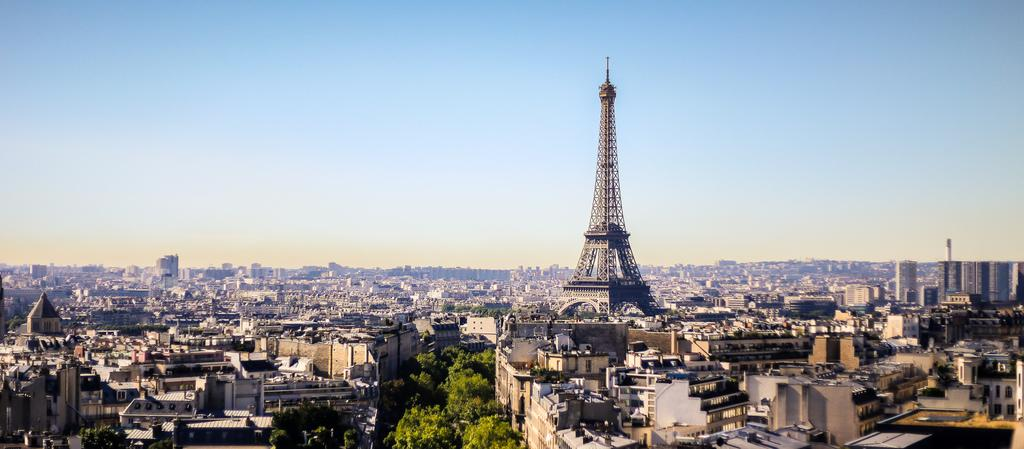What type of vegetation is at the bottom of the image? There are trees at the bottom of the image. What type of structures are in the middle of the image? There are buildings in the middle of the image. What famous landmark is present in the image? The Eiffel Tower is present in the image. What is visible at the top of the image? The sky is visible at the top of the image. What type of fruit is hanging from the trees at the bottom of the image? There is no fruit hanging from the trees in the image; only trees are present. What sign can be seen directing people to the Eiffel Tower in the image? There is no sign directing people to the Eiffel Tower in the image; the Eiffel Tower is already visible. 